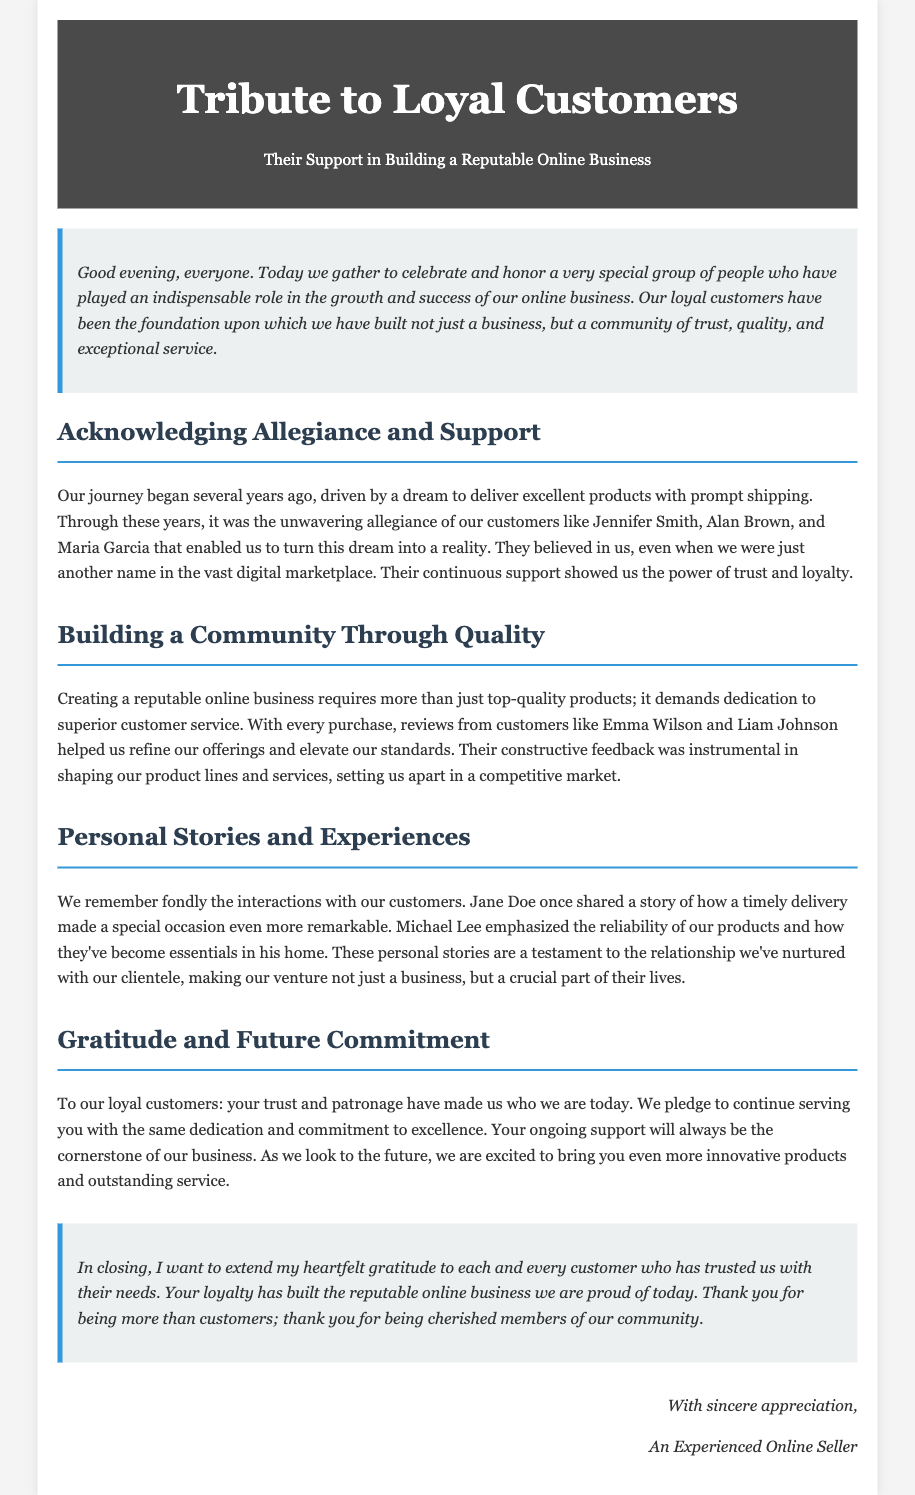What is the title of the document? The title is stated in the header of the document.
Answer: Tribute to Loyal Customers Who were mentioned as loyal customers in the eulogy? The document lists specific customers to acknowledge their support.
Answer: Jennifer Smith, Alan Brown, Maria Garcia What type of business is being honored in the eulogy? The document clearly describes the nature of the business.
Answer: Online business Which aspect of customer interaction is highlighted in the section "Personal Stories and Experiences"? The document discusses the importance of personal stories shared by customers.
Answer: Timely delivery What is the commitment made to loyal customers? The document states a pledge to customers in the "Gratitude and Future Commitment" section.
Answer: Continue serving with dedication How did customers like Emma Wilson and Liam Johnson contribute to the business improvement? The document explains how feedback from customers helped refine product offerings.
Answer: Constructive feedback 